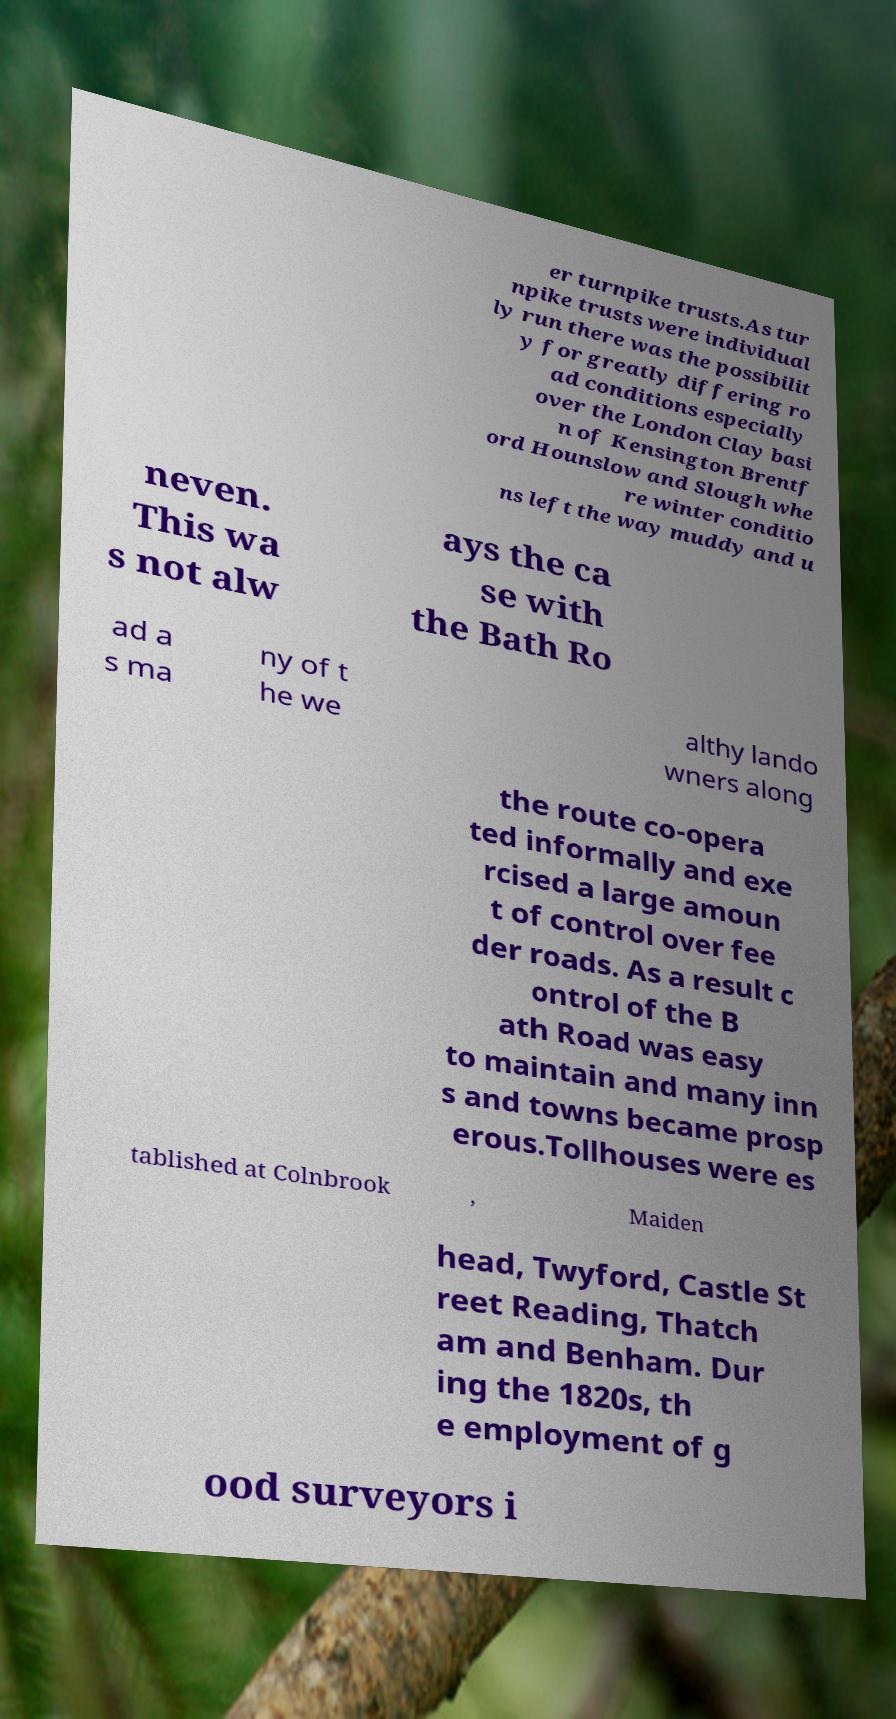Could you assist in decoding the text presented in this image and type it out clearly? er turnpike trusts.As tur npike trusts were individual ly run there was the possibilit y for greatly differing ro ad conditions especially over the London Clay basi n of Kensington Brentf ord Hounslow and Slough whe re winter conditio ns left the way muddy and u neven. This wa s not alw ays the ca se with the Bath Ro ad a s ma ny of t he we althy lando wners along the route co-opera ted informally and exe rcised a large amoun t of control over fee der roads. As a result c ontrol of the B ath Road was easy to maintain and many inn s and towns became prosp erous.Tollhouses were es tablished at Colnbrook , Maiden head, Twyford, Castle St reet Reading, Thatch am and Benham. Dur ing the 1820s, th e employment of g ood surveyors i 